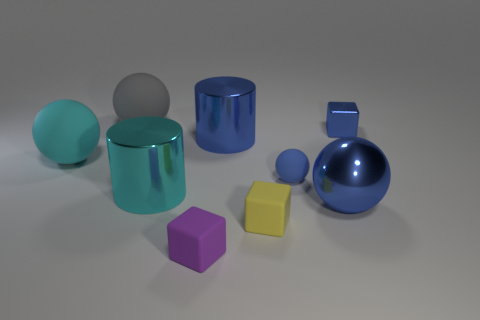Subtract 1 spheres. How many spheres are left? 3 Subtract all brown balls. Subtract all brown blocks. How many balls are left? 4 Add 1 small yellow metal cylinders. How many objects exist? 10 Subtract all cylinders. How many objects are left? 7 Add 6 yellow blocks. How many yellow blocks exist? 7 Subtract 0 gray cylinders. How many objects are left? 9 Subtract all large blue balls. Subtract all tiny rubber things. How many objects are left? 5 Add 7 small yellow matte cubes. How many small yellow matte cubes are left? 8 